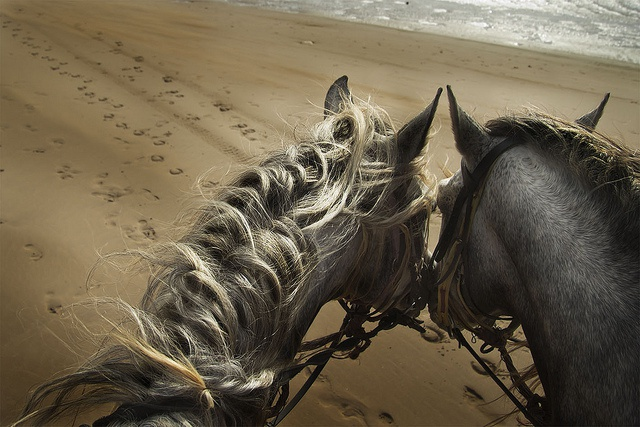Describe the objects in this image and their specific colors. I can see horse in olive, black, tan, and gray tones and horse in olive, black, and gray tones in this image. 